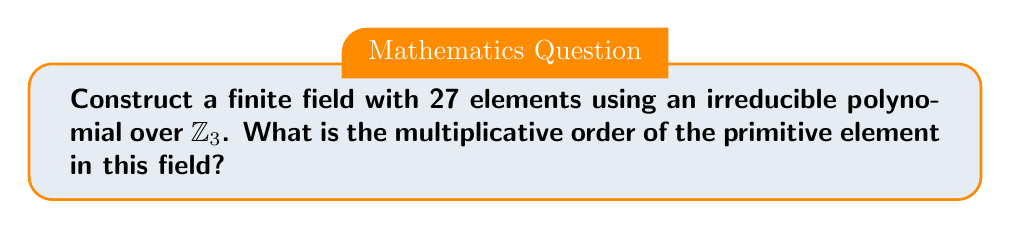What is the answer to this math problem? Let's approach this step-by-step:

1) To construct a finite field with 27 elements, we need to find an irreducible polynomial of degree 3 over $\mathbb{Z}_3$, as $3^3 = 27$.

2) One such irreducible polynomial is $f(x) = x^3 + 2x + 1$ over $\mathbb{Z}_3$.

3) The finite field is then $\mathbb{F}_{27} = \mathbb{Z}_3[x]/(f(x))$.

4) Let $\alpha$ be a root of $f(x)$ in $\mathbb{F}_{27}$. Then $\alpha^3 + 2\alpha + 1 = 0$ in $\mathbb{F}_{27}$.

5) The elements of $\mathbb{F}_{27}$ can be represented as $a_0 + a_1\alpha + a_2\alpha^2$, where $a_0, a_1, a_2 \in \mathbb{Z}_3$.

6) $\alpha$ is a primitive element of $\mathbb{F}_{27}$ if it generates all non-zero elements of the field.

7) The multiplicative group of $\mathbb{F}_{27}$ has order 26 (as there are 26 non-zero elements).

8) Therefore, the multiplicative order of the primitive element $\alpha$ is 26.

This construction mirrors the creation story in the Book of Genesis, where God created the world in 6 days and rested on the 7th, symbolizing perfection and completeness, much like how our finite field encompasses all 27 possible elements.
Answer: 26 